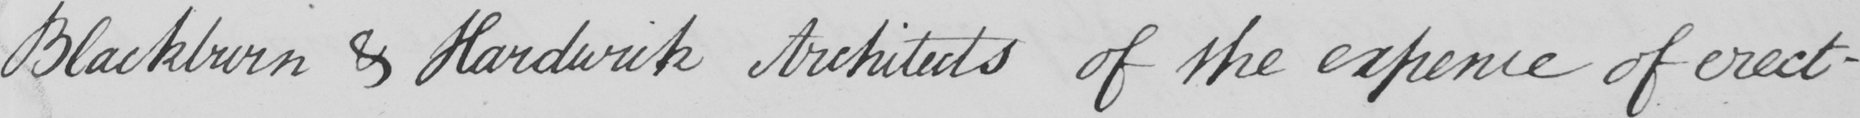What is written in this line of handwriting? Blackburn & Hardwick Architects of the expence of erecti- 